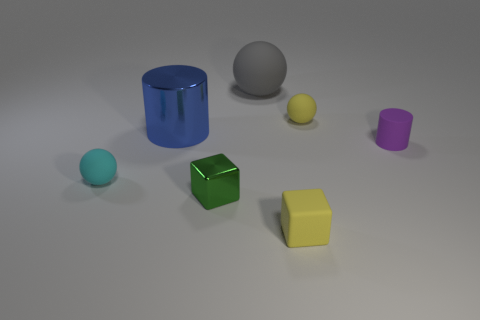Add 2 small cyan blocks. How many objects exist? 9 Subtract all cubes. How many objects are left? 5 Add 2 gray metal blocks. How many gray metal blocks exist? 2 Subtract 1 gray spheres. How many objects are left? 6 Subtract all small balls. Subtract all big gray metal things. How many objects are left? 5 Add 7 tiny green cubes. How many tiny green cubes are left? 8 